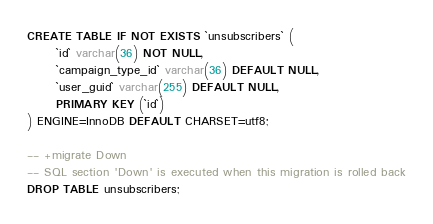<code> <loc_0><loc_0><loc_500><loc_500><_SQL_>CREATE TABLE IF NOT EXISTS `unsubscribers` (
      `id` varchar(36) NOT NULL,
      `campaign_type_id` varchar(36) DEFAULT NULL,
      `user_guid` varchar(255) DEFAULT NULL,
      PRIMARY KEY (`id`)
) ENGINE=InnoDB DEFAULT CHARSET=utf8;

-- +migrate Down
-- SQL section 'Down' is executed when this migration is rolled back
DROP TABLE unsubscribers;
</code> 